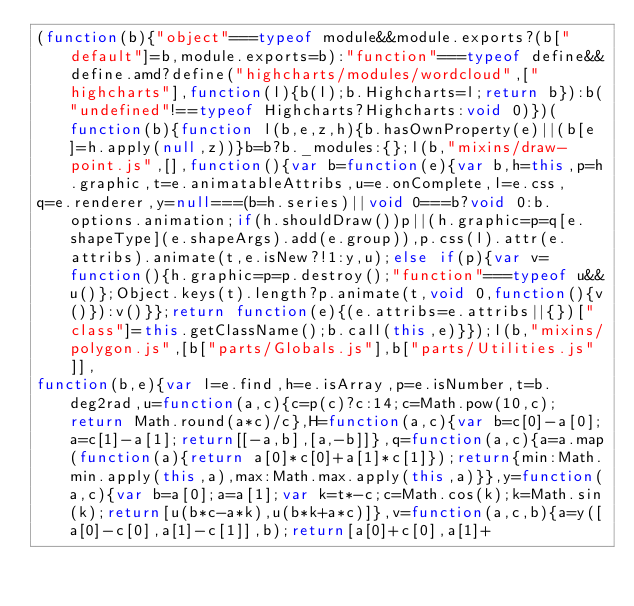Convert code to text. <code><loc_0><loc_0><loc_500><loc_500><_JavaScript_>(function(b){"object"===typeof module&&module.exports?(b["default"]=b,module.exports=b):"function"===typeof define&&define.amd?define("highcharts/modules/wordcloud",["highcharts"],function(l){b(l);b.Highcharts=l;return b}):b("undefined"!==typeof Highcharts?Highcharts:void 0)})(function(b){function l(b,e,z,h){b.hasOwnProperty(e)||(b[e]=h.apply(null,z))}b=b?b._modules:{};l(b,"mixins/draw-point.js",[],function(){var b=function(e){var b,h=this,p=h.graphic,t=e.animatableAttribs,u=e.onComplete,l=e.css,
q=e.renderer,y=null===(b=h.series)||void 0===b?void 0:b.options.animation;if(h.shouldDraw())p||(h.graphic=p=q[e.shapeType](e.shapeArgs).add(e.group)),p.css(l).attr(e.attribs).animate(t,e.isNew?!1:y,u);else if(p){var v=function(){h.graphic=p=p.destroy();"function"===typeof u&&u()};Object.keys(t).length?p.animate(t,void 0,function(){v()}):v()}};return function(e){(e.attribs=e.attribs||{})["class"]=this.getClassName();b.call(this,e)}});l(b,"mixins/polygon.js",[b["parts/Globals.js"],b["parts/Utilities.js"]],
function(b,e){var l=e.find,h=e.isArray,p=e.isNumber,t=b.deg2rad,u=function(a,c){c=p(c)?c:14;c=Math.pow(10,c);return Math.round(a*c)/c},H=function(a,c){var b=c[0]-a[0];a=c[1]-a[1];return[[-a,b],[a,-b]]},q=function(a,c){a=a.map(function(a){return a[0]*c[0]+a[1]*c[1]});return{min:Math.min.apply(this,a),max:Math.max.apply(this,a)}},y=function(a,c){var b=a[0];a=a[1];var k=t*-c;c=Math.cos(k);k=Math.sin(k);return[u(b*c-a*k),u(b*k+a*c)]},v=function(a,c,b){a=y([a[0]-c[0],a[1]-c[1]],b);return[a[0]+c[0],a[1]+</code> 